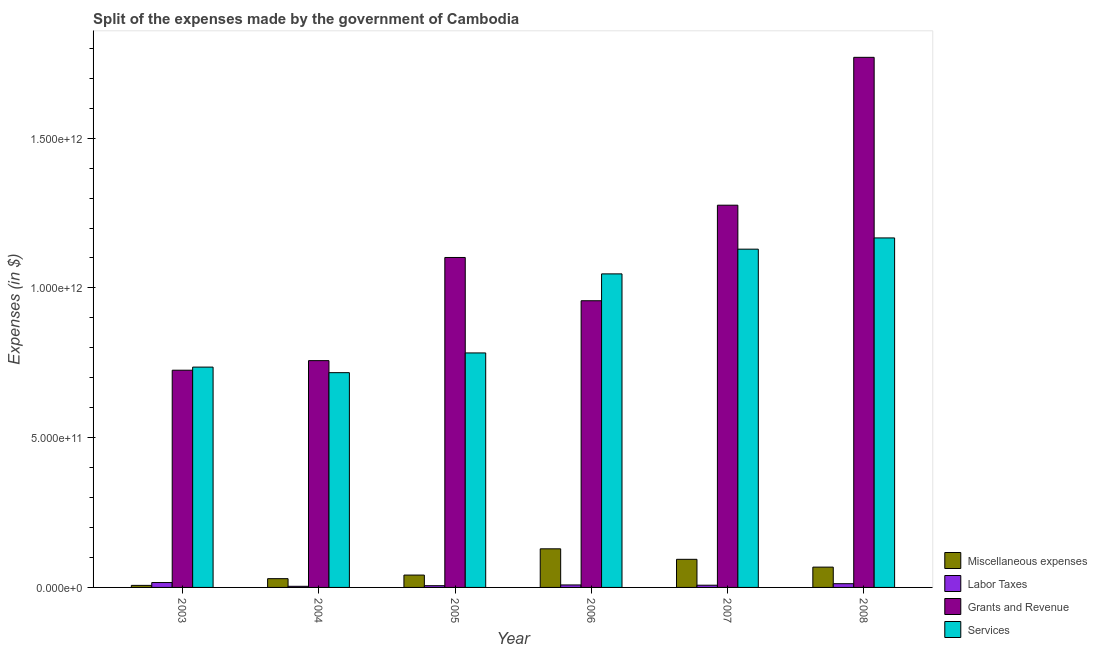How many groups of bars are there?
Your answer should be very brief. 6. How many bars are there on the 6th tick from the right?
Offer a terse response. 4. What is the label of the 5th group of bars from the left?
Provide a short and direct response. 2007. What is the amount spent on grants and revenue in 2008?
Give a very brief answer. 1.77e+12. Across all years, what is the maximum amount spent on grants and revenue?
Make the answer very short. 1.77e+12. Across all years, what is the minimum amount spent on miscellaneous expenses?
Your answer should be very brief. 6.80e+09. In which year was the amount spent on labor taxes maximum?
Make the answer very short. 2003. In which year was the amount spent on labor taxes minimum?
Ensure brevity in your answer.  2004. What is the total amount spent on labor taxes in the graph?
Keep it short and to the point. 5.40e+1. What is the difference between the amount spent on services in 2007 and that in 2008?
Your answer should be compact. -3.75e+1. What is the difference between the amount spent on grants and revenue in 2005 and the amount spent on labor taxes in 2006?
Offer a terse response. 1.44e+11. What is the average amount spent on services per year?
Offer a terse response. 9.30e+11. In the year 2005, what is the difference between the amount spent on services and amount spent on labor taxes?
Offer a terse response. 0. In how many years, is the amount spent on grants and revenue greater than 1100000000000 $?
Ensure brevity in your answer.  3. What is the ratio of the amount spent on grants and revenue in 2006 to that in 2008?
Your response must be concise. 0.54. What is the difference between the highest and the second highest amount spent on labor taxes?
Your answer should be very brief. 3.84e+09. What is the difference between the highest and the lowest amount spent on miscellaneous expenses?
Offer a very short reply. 1.22e+11. In how many years, is the amount spent on miscellaneous expenses greater than the average amount spent on miscellaneous expenses taken over all years?
Offer a very short reply. 3. Is the sum of the amount spent on miscellaneous expenses in 2004 and 2008 greater than the maximum amount spent on services across all years?
Your response must be concise. No. What does the 2nd bar from the left in 2007 represents?
Your response must be concise. Labor Taxes. What does the 2nd bar from the right in 2003 represents?
Provide a succinct answer. Grants and Revenue. How many bars are there?
Your answer should be compact. 24. What is the difference between two consecutive major ticks on the Y-axis?
Keep it short and to the point. 5.00e+11. Are the values on the major ticks of Y-axis written in scientific E-notation?
Provide a succinct answer. Yes. Does the graph contain any zero values?
Offer a very short reply. No. Does the graph contain grids?
Your answer should be compact. No. Where does the legend appear in the graph?
Give a very brief answer. Bottom right. What is the title of the graph?
Provide a succinct answer. Split of the expenses made by the government of Cambodia. Does "SF6 gas" appear as one of the legend labels in the graph?
Ensure brevity in your answer.  No. What is the label or title of the X-axis?
Offer a terse response. Year. What is the label or title of the Y-axis?
Your answer should be compact. Expenses (in $). What is the Expenses (in $) in Miscellaneous expenses in 2003?
Keep it short and to the point. 6.80e+09. What is the Expenses (in $) in Labor Taxes in 2003?
Your answer should be compact. 1.63e+1. What is the Expenses (in $) of Grants and Revenue in 2003?
Provide a succinct answer. 7.25e+11. What is the Expenses (in $) in Services in 2003?
Your answer should be compact. 7.36e+11. What is the Expenses (in $) in Miscellaneous expenses in 2004?
Your response must be concise. 2.93e+1. What is the Expenses (in $) in Labor Taxes in 2004?
Your response must be concise. 3.76e+09. What is the Expenses (in $) of Grants and Revenue in 2004?
Keep it short and to the point. 7.57e+11. What is the Expenses (in $) of Services in 2004?
Your answer should be compact. 7.17e+11. What is the Expenses (in $) in Miscellaneous expenses in 2005?
Offer a terse response. 4.13e+1. What is the Expenses (in $) of Labor Taxes in 2005?
Offer a very short reply. 5.77e+09. What is the Expenses (in $) of Grants and Revenue in 2005?
Make the answer very short. 1.10e+12. What is the Expenses (in $) in Services in 2005?
Your answer should be very brief. 7.83e+11. What is the Expenses (in $) in Miscellaneous expenses in 2006?
Your answer should be compact. 1.29e+11. What is the Expenses (in $) of Labor Taxes in 2006?
Your answer should be very brief. 8.30e+09. What is the Expenses (in $) of Grants and Revenue in 2006?
Your answer should be compact. 9.57e+11. What is the Expenses (in $) of Services in 2006?
Provide a succinct answer. 1.05e+12. What is the Expenses (in $) in Miscellaneous expenses in 2007?
Your answer should be compact. 9.39e+1. What is the Expenses (in $) in Labor Taxes in 2007?
Your answer should be compact. 7.42e+09. What is the Expenses (in $) in Grants and Revenue in 2007?
Give a very brief answer. 1.28e+12. What is the Expenses (in $) in Services in 2007?
Provide a short and direct response. 1.13e+12. What is the Expenses (in $) in Miscellaneous expenses in 2008?
Ensure brevity in your answer.  6.78e+1. What is the Expenses (in $) in Labor Taxes in 2008?
Make the answer very short. 1.25e+1. What is the Expenses (in $) of Grants and Revenue in 2008?
Your response must be concise. 1.77e+12. What is the Expenses (in $) in Services in 2008?
Give a very brief answer. 1.17e+12. Across all years, what is the maximum Expenses (in $) in Miscellaneous expenses?
Offer a very short reply. 1.29e+11. Across all years, what is the maximum Expenses (in $) in Labor Taxes?
Your response must be concise. 1.63e+1. Across all years, what is the maximum Expenses (in $) in Grants and Revenue?
Provide a succinct answer. 1.77e+12. Across all years, what is the maximum Expenses (in $) of Services?
Your answer should be compact. 1.17e+12. Across all years, what is the minimum Expenses (in $) in Miscellaneous expenses?
Offer a very short reply. 6.80e+09. Across all years, what is the minimum Expenses (in $) of Labor Taxes?
Offer a very short reply. 3.76e+09. Across all years, what is the minimum Expenses (in $) of Grants and Revenue?
Provide a succinct answer. 7.25e+11. Across all years, what is the minimum Expenses (in $) of Services?
Your response must be concise. 7.17e+11. What is the total Expenses (in $) of Miscellaneous expenses in the graph?
Provide a short and direct response. 3.68e+11. What is the total Expenses (in $) in Labor Taxes in the graph?
Your answer should be very brief. 5.40e+1. What is the total Expenses (in $) of Grants and Revenue in the graph?
Provide a succinct answer. 6.59e+12. What is the total Expenses (in $) of Services in the graph?
Make the answer very short. 5.58e+12. What is the difference between the Expenses (in $) in Miscellaneous expenses in 2003 and that in 2004?
Keep it short and to the point. -2.25e+1. What is the difference between the Expenses (in $) of Labor Taxes in 2003 and that in 2004?
Make the answer very short. 1.26e+1. What is the difference between the Expenses (in $) in Grants and Revenue in 2003 and that in 2004?
Provide a short and direct response. -3.20e+1. What is the difference between the Expenses (in $) in Services in 2003 and that in 2004?
Keep it short and to the point. 1.86e+1. What is the difference between the Expenses (in $) of Miscellaneous expenses in 2003 and that in 2005?
Your response must be concise. -3.45e+1. What is the difference between the Expenses (in $) of Labor Taxes in 2003 and that in 2005?
Ensure brevity in your answer.  1.05e+1. What is the difference between the Expenses (in $) of Grants and Revenue in 2003 and that in 2005?
Make the answer very short. -3.76e+11. What is the difference between the Expenses (in $) in Services in 2003 and that in 2005?
Provide a succinct answer. -4.73e+1. What is the difference between the Expenses (in $) of Miscellaneous expenses in 2003 and that in 2006?
Ensure brevity in your answer.  -1.22e+11. What is the difference between the Expenses (in $) of Labor Taxes in 2003 and that in 2006?
Your response must be concise. 8.01e+09. What is the difference between the Expenses (in $) in Grants and Revenue in 2003 and that in 2006?
Ensure brevity in your answer.  -2.32e+11. What is the difference between the Expenses (in $) of Services in 2003 and that in 2006?
Offer a terse response. -3.11e+11. What is the difference between the Expenses (in $) in Miscellaneous expenses in 2003 and that in 2007?
Your answer should be compact. -8.71e+1. What is the difference between the Expenses (in $) in Labor Taxes in 2003 and that in 2007?
Your answer should be compact. 8.90e+09. What is the difference between the Expenses (in $) in Grants and Revenue in 2003 and that in 2007?
Provide a succinct answer. -5.51e+11. What is the difference between the Expenses (in $) of Services in 2003 and that in 2007?
Your answer should be compact. -3.94e+11. What is the difference between the Expenses (in $) in Miscellaneous expenses in 2003 and that in 2008?
Provide a succinct answer. -6.10e+1. What is the difference between the Expenses (in $) in Labor Taxes in 2003 and that in 2008?
Provide a succinct answer. 3.84e+09. What is the difference between the Expenses (in $) in Grants and Revenue in 2003 and that in 2008?
Give a very brief answer. -1.04e+12. What is the difference between the Expenses (in $) of Services in 2003 and that in 2008?
Keep it short and to the point. -4.31e+11. What is the difference between the Expenses (in $) in Miscellaneous expenses in 2004 and that in 2005?
Provide a short and direct response. -1.20e+1. What is the difference between the Expenses (in $) of Labor Taxes in 2004 and that in 2005?
Keep it short and to the point. -2.01e+09. What is the difference between the Expenses (in $) of Grants and Revenue in 2004 and that in 2005?
Your response must be concise. -3.44e+11. What is the difference between the Expenses (in $) in Services in 2004 and that in 2005?
Make the answer very short. -6.59e+1. What is the difference between the Expenses (in $) of Miscellaneous expenses in 2004 and that in 2006?
Give a very brief answer. -9.96e+1. What is the difference between the Expenses (in $) in Labor Taxes in 2004 and that in 2006?
Make the answer very short. -4.54e+09. What is the difference between the Expenses (in $) of Grants and Revenue in 2004 and that in 2006?
Keep it short and to the point. -2.00e+11. What is the difference between the Expenses (in $) of Services in 2004 and that in 2006?
Offer a terse response. -3.30e+11. What is the difference between the Expenses (in $) of Miscellaneous expenses in 2004 and that in 2007?
Your response must be concise. -6.46e+1. What is the difference between the Expenses (in $) in Labor Taxes in 2004 and that in 2007?
Offer a very short reply. -3.66e+09. What is the difference between the Expenses (in $) of Grants and Revenue in 2004 and that in 2007?
Your answer should be compact. -5.19e+11. What is the difference between the Expenses (in $) in Services in 2004 and that in 2007?
Make the answer very short. -4.12e+11. What is the difference between the Expenses (in $) of Miscellaneous expenses in 2004 and that in 2008?
Your response must be concise. -3.86e+1. What is the difference between the Expenses (in $) in Labor Taxes in 2004 and that in 2008?
Provide a succinct answer. -8.72e+09. What is the difference between the Expenses (in $) of Grants and Revenue in 2004 and that in 2008?
Give a very brief answer. -1.01e+12. What is the difference between the Expenses (in $) of Services in 2004 and that in 2008?
Offer a terse response. -4.50e+11. What is the difference between the Expenses (in $) in Miscellaneous expenses in 2005 and that in 2006?
Your answer should be compact. -8.76e+1. What is the difference between the Expenses (in $) in Labor Taxes in 2005 and that in 2006?
Offer a terse response. -2.54e+09. What is the difference between the Expenses (in $) of Grants and Revenue in 2005 and that in 2006?
Your answer should be compact. 1.44e+11. What is the difference between the Expenses (in $) in Services in 2005 and that in 2006?
Make the answer very short. -2.64e+11. What is the difference between the Expenses (in $) in Miscellaneous expenses in 2005 and that in 2007?
Keep it short and to the point. -5.26e+1. What is the difference between the Expenses (in $) of Labor Taxes in 2005 and that in 2007?
Your answer should be very brief. -1.65e+09. What is the difference between the Expenses (in $) in Grants and Revenue in 2005 and that in 2007?
Your response must be concise. -1.75e+11. What is the difference between the Expenses (in $) in Services in 2005 and that in 2007?
Provide a short and direct response. -3.46e+11. What is the difference between the Expenses (in $) in Miscellaneous expenses in 2005 and that in 2008?
Provide a succinct answer. -2.66e+1. What is the difference between the Expenses (in $) in Labor Taxes in 2005 and that in 2008?
Your answer should be very brief. -6.71e+09. What is the difference between the Expenses (in $) of Grants and Revenue in 2005 and that in 2008?
Keep it short and to the point. -6.68e+11. What is the difference between the Expenses (in $) in Services in 2005 and that in 2008?
Provide a succinct answer. -3.84e+11. What is the difference between the Expenses (in $) in Miscellaneous expenses in 2006 and that in 2007?
Keep it short and to the point. 3.50e+1. What is the difference between the Expenses (in $) of Labor Taxes in 2006 and that in 2007?
Your response must be concise. 8.87e+08. What is the difference between the Expenses (in $) of Grants and Revenue in 2006 and that in 2007?
Keep it short and to the point. -3.19e+11. What is the difference between the Expenses (in $) in Services in 2006 and that in 2007?
Ensure brevity in your answer.  -8.25e+1. What is the difference between the Expenses (in $) of Miscellaneous expenses in 2006 and that in 2008?
Keep it short and to the point. 6.11e+1. What is the difference between the Expenses (in $) in Labor Taxes in 2006 and that in 2008?
Make the answer very short. -4.17e+09. What is the difference between the Expenses (in $) in Grants and Revenue in 2006 and that in 2008?
Your answer should be very brief. -8.13e+11. What is the difference between the Expenses (in $) in Services in 2006 and that in 2008?
Make the answer very short. -1.20e+11. What is the difference between the Expenses (in $) of Miscellaneous expenses in 2007 and that in 2008?
Provide a short and direct response. 2.60e+1. What is the difference between the Expenses (in $) in Labor Taxes in 2007 and that in 2008?
Your response must be concise. -5.06e+09. What is the difference between the Expenses (in $) of Grants and Revenue in 2007 and that in 2008?
Provide a short and direct response. -4.94e+11. What is the difference between the Expenses (in $) of Services in 2007 and that in 2008?
Your answer should be compact. -3.75e+1. What is the difference between the Expenses (in $) of Miscellaneous expenses in 2003 and the Expenses (in $) of Labor Taxes in 2004?
Your answer should be very brief. 3.04e+09. What is the difference between the Expenses (in $) of Miscellaneous expenses in 2003 and the Expenses (in $) of Grants and Revenue in 2004?
Give a very brief answer. -7.50e+11. What is the difference between the Expenses (in $) in Miscellaneous expenses in 2003 and the Expenses (in $) in Services in 2004?
Provide a succinct answer. -7.10e+11. What is the difference between the Expenses (in $) in Labor Taxes in 2003 and the Expenses (in $) in Grants and Revenue in 2004?
Your response must be concise. -7.41e+11. What is the difference between the Expenses (in $) of Labor Taxes in 2003 and the Expenses (in $) of Services in 2004?
Provide a succinct answer. -7.01e+11. What is the difference between the Expenses (in $) of Grants and Revenue in 2003 and the Expenses (in $) of Services in 2004?
Your response must be concise. 8.16e+09. What is the difference between the Expenses (in $) of Miscellaneous expenses in 2003 and the Expenses (in $) of Labor Taxes in 2005?
Offer a terse response. 1.03e+09. What is the difference between the Expenses (in $) in Miscellaneous expenses in 2003 and the Expenses (in $) in Grants and Revenue in 2005?
Keep it short and to the point. -1.09e+12. What is the difference between the Expenses (in $) of Miscellaneous expenses in 2003 and the Expenses (in $) of Services in 2005?
Ensure brevity in your answer.  -7.76e+11. What is the difference between the Expenses (in $) of Labor Taxes in 2003 and the Expenses (in $) of Grants and Revenue in 2005?
Provide a short and direct response. -1.09e+12. What is the difference between the Expenses (in $) of Labor Taxes in 2003 and the Expenses (in $) of Services in 2005?
Your response must be concise. -7.67e+11. What is the difference between the Expenses (in $) in Grants and Revenue in 2003 and the Expenses (in $) in Services in 2005?
Provide a succinct answer. -5.77e+1. What is the difference between the Expenses (in $) of Miscellaneous expenses in 2003 and the Expenses (in $) of Labor Taxes in 2006?
Give a very brief answer. -1.51e+09. What is the difference between the Expenses (in $) of Miscellaneous expenses in 2003 and the Expenses (in $) of Grants and Revenue in 2006?
Provide a succinct answer. -9.50e+11. What is the difference between the Expenses (in $) in Miscellaneous expenses in 2003 and the Expenses (in $) in Services in 2006?
Your response must be concise. -1.04e+12. What is the difference between the Expenses (in $) in Labor Taxes in 2003 and the Expenses (in $) in Grants and Revenue in 2006?
Provide a short and direct response. -9.41e+11. What is the difference between the Expenses (in $) of Labor Taxes in 2003 and the Expenses (in $) of Services in 2006?
Offer a terse response. -1.03e+12. What is the difference between the Expenses (in $) in Grants and Revenue in 2003 and the Expenses (in $) in Services in 2006?
Your response must be concise. -3.22e+11. What is the difference between the Expenses (in $) in Miscellaneous expenses in 2003 and the Expenses (in $) in Labor Taxes in 2007?
Provide a succinct answer. -6.19e+08. What is the difference between the Expenses (in $) in Miscellaneous expenses in 2003 and the Expenses (in $) in Grants and Revenue in 2007?
Offer a very short reply. -1.27e+12. What is the difference between the Expenses (in $) in Miscellaneous expenses in 2003 and the Expenses (in $) in Services in 2007?
Your answer should be very brief. -1.12e+12. What is the difference between the Expenses (in $) in Labor Taxes in 2003 and the Expenses (in $) in Grants and Revenue in 2007?
Make the answer very short. -1.26e+12. What is the difference between the Expenses (in $) of Labor Taxes in 2003 and the Expenses (in $) of Services in 2007?
Offer a very short reply. -1.11e+12. What is the difference between the Expenses (in $) of Grants and Revenue in 2003 and the Expenses (in $) of Services in 2007?
Offer a very short reply. -4.04e+11. What is the difference between the Expenses (in $) of Miscellaneous expenses in 2003 and the Expenses (in $) of Labor Taxes in 2008?
Your answer should be very brief. -5.68e+09. What is the difference between the Expenses (in $) of Miscellaneous expenses in 2003 and the Expenses (in $) of Grants and Revenue in 2008?
Your answer should be very brief. -1.76e+12. What is the difference between the Expenses (in $) in Miscellaneous expenses in 2003 and the Expenses (in $) in Services in 2008?
Provide a short and direct response. -1.16e+12. What is the difference between the Expenses (in $) of Labor Taxes in 2003 and the Expenses (in $) of Grants and Revenue in 2008?
Your answer should be very brief. -1.75e+12. What is the difference between the Expenses (in $) of Labor Taxes in 2003 and the Expenses (in $) of Services in 2008?
Provide a short and direct response. -1.15e+12. What is the difference between the Expenses (in $) in Grants and Revenue in 2003 and the Expenses (in $) in Services in 2008?
Your answer should be compact. -4.42e+11. What is the difference between the Expenses (in $) of Miscellaneous expenses in 2004 and the Expenses (in $) of Labor Taxes in 2005?
Offer a terse response. 2.35e+1. What is the difference between the Expenses (in $) of Miscellaneous expenses in 2004 and the Expenses (in $) of Grants and Revenue in 2005?
Your response must be concise. -1.07e+12. What is the difference between the Expenses (in $) in Miscellaneous expenses in 2004 and the Expenses (in $) in Services in 2005?
Keep it short and to the point. -7.54e+11. What is the difference between the Expenses (in $) of Labor Taxes in 2004 and the Expenses (in $) of Grants and Revenue in 2005?
Your response must be concise. -1.10e+12. What is the difference between the Expenses (in $) in Labor Taxes in 2004 and the Expenses (in $) in Services in 2005?
Give a very brief answer. -7.79e+11. What is the difference between the Expenses (in $) in Grants and Revenue in 2004 and the Expenses (in $) in Services in 2005?
Offer a very short reply. -2.57e+1. What is the difference between the Expenses (in $) of Miscellaneous expenses in 2004 and the Expenses (in $) of Labor Taxes in 2006?
Give a very brief answer. 2.10e+1. What is the difference between the Expenses (in $) of Miscellaneous expenses in 2004 and the Expenses (in $) of Grants and Revenue in 2006?
Give a very brief answer. -9.28e+11. What is the difference between the Expenses (in $) in Miscellaneous expenses in 2004 and the Expenses (in $) in Services in 2006?
Offer a very short reply. -1.02e+12. What is the difference between the Expenses (in $) of Labor Taxes in 2004 and the Expenses (in $) of Grants and Revenue in 2006?
Make the answer very short. -9.53e+11. What is the difference between the Expenses (in $) in Labor Taxes in 2004 and the Expenses (in $) in Services in 2006?
Make the answer very short. -1.04e+12. What is the difference between the Expenses (in $) in Grants and Revenue in 2004 and the Expenses (in $) in Services in 2006?
Offer a very short reply. -2.90e+11. What is the difference between the Expenses (in $) of Miscellaneous expenses in 2004 and the Expenses (in $) of Labor Taxes in 2007?
Provide a short and direct response. 2.19e+1. What is the difference between the Expenses (in $) in Miscellaneous expenses in 2004 and the Expenses (in $) in Grants and Revenue in 2007?
Provide a short and direct response. -1.25e+12. What is the difference between the Expenses (in $) in Miscellaneous expenses in 2004 and the Expenses (in $) in Services in 2007?
Your answer should be compact. -1.10e+12. What is the difference between the Expenses (in $) of Labor Taxes in 2004 and the Expenses (in $) of Grants and Revenue in 2007?
Ensure brevity in your answer.  -1.27e+12. What is the difference between the Expenses (in $) in Labor Taxes in 2004 and the Expenses (in $) in Services in 2007?
Keep it short and to the point. -1.13e+12. What is the difference between the Expenses (in $) in Grants and Revenue in 2004 and the Expenses (in $) in Services in 2007?
Your response must be concise. -3.72e+11. What is the difference between the Expenses (in $) in Miscellaneous expenses in 2004 and the Expenses (in $) in Labor Taxes in 2008?
Ensure brevity in your answer.  1.68e+1. What is the difference between the Expenses (in $) of Miscellaneous expenses in 2004 and the Expenses (in $) of Grants and Revenue in 2008?
Make the answer very short. -1.74e+12. What is the difference between the Expenses (in $) of Miscellaneous expenses in 2004 and the Expenses (in $) of Services in 2008?
Your response must be concise. -1.14e+12. What is the difference between the Expenses (in $) in Labor Taxes in 2004 and the Expenses (in $) in Grants and Revenue in 2008?
Offer a very short reply. -1.77e+12. What is the difference between the Expenses (in $) of Labor Taxes in 2004 and the Expenses (in $) of Services in 2008?
Provide a short and direct response. -1.16e+12. What is the difference between the Expenses (in $) of Grants and Revenue in 2004 and the Expenses (in $) of Services in 2008?
Give a very brief answer. -4.10e+11. What is the difference between the Expenses (in $) in Miscellaneous expenses in 2005 and the Expenses (in $) in Labor Taxes in 2006?
Offer a terse response. 3.30e+1. What is the difference between the Expenses (in $) in Miscellaneous expenses in 2005 and the Expenses (in $) in Grants and Revenue in 2006?
Ensure brevity in your answer.  -9.16e+11. What is the difference between the Expenses (in $) in Miscellaneous expenses in 2005 and the Expenses (in $) in Services in 2006?
Offer a terse response. -1.01e+12. What is the difference between the Expenses (in $) of Labor Taxes in 2005 and the Expenses (in $) of Grants and Revenue in 2006?
Your response must be concise. -9.51e+11. What is the difference between the Expenses (in $) in Labor Taxes in 2005 and the Expenses (in $) in Services in 2006?
Provide a succinct answer. -1.04e+12. What is the difference between the Expenses (in $) of Grants and Revenue in 2005 and the Expenses (in $) of Services in 2006?
Your answer should be very brief. 5.48e+1. What is the difference between the Expenses (in $) in Miscellaneous expenses in 2005 and the Expenses (in $) in Labor Taxes in 2007?
Your response must be concise. 3.39e+1. What is the difference between the Expenses (in $) in Miscellaneous expenses in 2005 and the Expenses (in $) in Grants and Revenue in 2007?
Provide a short and direct response. -1.23e+12. What is the difference between the Expenses (in $) in Miscellaneous expenses in 2005 and the Expenses (in $) in Services in 2007?
Your response must be concise. -1.09e+12. What is the difference between the Expenses (in $) in Labor Taxes in 2005 and the Expenses (in $) in Grants and Revenue in 2007?
Provide a succinct answer. -1.27e+12. What is the difference between the Expenses (in $) in Labor Taxes in 2005 and the Expenses (in $) in Services in 2007?
Offer a terse response. -1.12e+12. What is the difference between the Expenses (in $) of Grants and Revenue in 2005 and the Expenses (in $) of Services in 2007?
Your response must be concise. -2.78e+1. What is the difference between the Expenses (in $) in Miscellaneous expenses in 2005 and the Expenses (in $) in Labor Taxes in 2008?
Ensure brevity in your answer.  2.88e+1. What is the difference between the Expenses (in $) of Miscellaneous expenses in 2005 and the Expenses (in $) of Grants and Revenue in 2008?
Provide a succinct answer. -1.73e+12. What is the difference between the Expenses (in $) of Miscellaneous expenses in 2005 and the Expenses (in $) of Services in 2008?
Provide a short and direct response. -1.13e+12. What is the difference between the Expenses (in $) in Labor Taxes in 2005 and the Expenses (in $) in Grants and Revenue in 2008?
Keep it short and to the point. -1.76e+12. What is the difference between the Expenses (in $) of Labor Taxes in 2005 and the Expenses (in $) of Services in 2008?
Offer a very short reply. -1.16e+12. What is the difference between the Expenses (in $) of Grants and Revenue in 2005 and the Expenses (in $) of Services in 2008?
Provide a succinct answer. -6.53e+1. What is the difference between the Expenses (in $) of Miscellaneous expenses in 2006 and the Expenses (in $) of Labor Taxes in 2007?
Keep it short and to the point. 1.21e+11. What is the difference between the Expenses (in $) in Miscellaneous expenses in 2006 and the Expenses (in $) in Grants and Revenue in 2007?
Your answer should be very brief. -1.15e+12. What is the difference between the Expenses (in $) of Miscellaneous expenses in 2006 and the Expenses (in $) of Services in 2007?
Make the answer very short. -1.00e+12. What is the difference between the Expenses (in $) of Labor Taxes in 2006 and the Expenses (in $) of Grants and Revenue in 2007?
Provide a succinct answer. -1.27e+12. What is the difference between the Expenses (in $) in Labor Taxes in 2006 and the Expenses (in $) in Services in 2007?
Give a very brief answer. -1.12e+12. What is the difference between the Expenses (in $) in Grants and Revenue in 2006 and the Expenses (in $) in Services in 2007?
Make the answer very short. -1.72e+11. What is the difference between the Expenses (in $) of Miscellaneous expenses in 2006 and the Expenses (in $) of Labor Taxes in 2008?
Your answer should be compact. 1.16e+11. What is the difference between the Expenses (in $) of Miscellaneous expenses in 2006 and the Expenses (in $) of Grants and Revenue in 2008?
Keep it short and to the point. -1.64e+12. What is the difference between the Expenses (in $) of Miscellaneous expenses in 2006 and the Expenses (in $) of Services in 2008?
Your response must be concise. -1.04e+12. What is the difference between the Expenses (in $) of Labor Taxes in 2006 and the Expenses (in $) of Grants and Revenue in 2008?
Offer a very short reply. -1.76e+12. What is the difference between the Expenses (in $) of Labor Taxes in 2006 and the Expenses (in $) of Services in 2008?
Make the answer very short. -1.16e+12. What is the difference between the Expenses (in $) in Grants and Revenue in 2006 and the Expenses (in $) in Services in 2008?
Give a very brief answer. -2.10e+11. What is the difference between the Expenses (in $) in Miscellaneous expenses in 2007 and the Expenses (in $) in Labor Taxes in 2008?
Keep it short and to the point. 8.14e+1. What is the difference between the Expenses (in $) in Miscellaneous expenses in 2007 and the Expenses (in $) in Grants and Revenue in 2008?
Offer a terse response. -1.68e+12. What is the difference between the Expenses (in $) of Miscellaneous expenses in 2007 and the Expenses (in $) of Services in 2008?
Offer a very short reply. -1.07e+12. What is the difference between the Expenses (in $) in Labor Taxes in 2007 and the Expenses (in $) in Grants and Revenue in 2008?
Keep it short and to the point. -1.76e+12. What is the difference between the Expenses (in $) in Labor Taxes in 2007 and the Expenses (in $) in Services in 2008?
Offer a terse response. -1.16e+12. What is the difference between the Expenses (in $) of Grants and Revenue in 2007 and the Expenses (in $) of Services in 2008?
Give a very brief answer. 1.09e+11. What is the average Expenses (in $) of Miscellaneous expenses per year?
Keep it short and to the point. 6.13e+1. What is the average Expenses (in $) in Labor Taxes per year?
Provide a short and direct response. 9.01e+09. What is the average Expenses (in $) of Grants and Revenue per year?
Your answer should be very brief. 1.10e+12. What is the average Expenses (in $) of Services per year?
Keep it short and to the point. 9.30e+11. In the year 2003, what is the difference between the Expenses (in $) of Miscellaneous expenses and Expenses (in $) of Labor Taxes?
Offer a very short reply. -9.52e+09. In the year 2003, what is the difference between the Expenses (in $) of Miscellaneous expenses and Expenses (in $) of Grants and Revenue?
Make the answer very short. -7.18e+11. In the year 2003, what is the difference between the Expenses (in $) in Miscellaneous expenses and Expenses (in $) in Services?
Your answer should be compact. -7.29e+11. In the year 2003, what is the difference between the Expenses (in $) of Labor Taxes and Expenses (in $) of Grants and Revenue?
Your answer should be compact. -7.09e+11. In the year 2003, what is the difference between the Expenses (in $) in Labor Taxes and Expenses (in $) in Services?
Your answer should be very brief. -7.19e+11. In the year 2003, what is the difference between the Expenses (in $) of Grants and Revenue and Expenses (in $) of Services?
Ensure brevity in your answer.  -1.04e+1. In the year 2004, what is the difference between the Expenses (in $) in Miscellaneous expenses and Expenses (in $) in Labor Taxes?
Give a very brief answer. 2.55e+1. In the year 2004, what is the difference between the Expenses (in $) of Miscellaneous expenses and Expenses (in $) of Grants and Revenue?
Your response must be concise. -7.28e+11. In the year 2004, what is the difference between the Expenses (in $) of Miscellaneous expenses and Expenses (in $) of Services?
Your answer should be compact. -6.88e+11. In the year 2004, what is the difference between the Expenses (in $) of Labor Taxes and Expenses (in $) of Grants and Revenue?
Provide a succinct answer. -7.53e+11. In the year 2004, what is the difference between the Expenses (in $) of Labor Taxes and Expenses (in $) of Services?
Provide a succinct answer. -7.13e+11. In the year 2004, what is the difference between the Expenses (in $) of Grants and Revenue and Expenses (in $) of Services?
Provide a succinct answer. 4.02e+1. In the year 2005, what is the difference between the Expenses (in $) in Miscellaneous expenses and Expenses (in $) in Labor Taxes?
Provide a succinct answer. 3.55e+1. In the year 2005, what is the difference between the Expenses (in $) in Miscellaneous expenses and Expenses (in $) in Grants and Revenue?
Keep it short and to the point. -1.06e+12. In the year 2005, what is the difference between the Expenses (in $) in Miscellaneous expenses and Expenses (in $) in Services?
Provide a short and direct response. -7.42e+11. In the year 2005, what is the difference between the Expenses (in $) in Labor Taxes and Expenses (in $) in Grants and Revenue?
Provide a short and direct response. -1.10e+12. In the year 2005, what is the difference between the Expenses (in $) in Labor Taxes and Expenses (in $) in Services?
Provide a short and direct response. -7.77e+11. In the year 2005, what is the difference between the Expenses (in $) of Grants and Revenue and Expenses (in $) of Services?
Give a very brief answer. 3.19e+11. In the year 2006, what is the difference between the Expenses (in $) of Miscellaneous expenses and Expenses (in $) of Labor Taxes?
Provide a short and direct response. 1.21e+11. In the year 2006, what is the difference between the Expenses (in $) of Miscellaneous expenses and Expenses (in $) of Grants and Revenue?
Provide a short and direct response. -8.28e+11. In the year 2006, what is the difference between the Expenses (in $) in Miscellaneous expenses and Expenses (in $) in Services?
Provide a short and direct response. -9.18e+11. In the year 2006, what is the difference between the Expenses (in $) in Labor Taxes and Expenses (in $) in Grants and Revenue?
Make the answer very short. -9.49e+11. In the year 2006, what is the difference between the Expenses (in $) of Labor Taxes and Expenses (in $) of Services?
Your response must be concise. -1.04e+12. In the year 2006, what is the difference between the Expenses (in $) in Grants and Revenue and Expenses (in $) in Services?
Give a very brief answer. -8.97e+1. In the year 2007, what is the difference between the Expenses (in $) in Miscellaneous expenses and Expenses (in $) in Labor Taxes?
Your response must be concise. 8.64e+1. In the year 2007, what is the difference between the Expenses (in $) in Miscellaneous expenses and Expenses (in $) in Grants and Revenue?
Make the answer very short. -1.18e+12. In the year 2007, what is the difference between the Expenses (in $) of Miscellaneous expenses and Expenses (in $) of Services?
Your answer should be compact. -1.04e+12. In the year 2007, what is the difference between the Expenses (in $) in Labor Taxes and Expenses (in $) in Grants and Revenue?
Offer a very short reply. -1.27e+12. In the year 2007, what is the difference between the Expenses (in $) in Labor Taxes and Expenses (in $) in Services?
Make the answer very short. -1.12e+12. In the year 2007, what is the difference between the Expenses (in $) of Grants and Revenue and Expenses (in $) of Services?
Offer a very short reply. 1.47e+11. In the year 2008, what is the difference between the Expenses (in $) of Miscellaneous expenses and Expenses (in $) of Labor Taxes?
Provide a short and direct response. 5.54e+1. In the year 2008, what is the difference between the Expenses (in $) of Miscellaneous expenses and Expenses (in $) of Grants and Revenue?
Ensure brevity in your answer.  -1.70e+12. In the year 2008, what is the difference between the Expenses (in $) of Miscellaneous expenses and Expenses (in $) of Services?
Make the answer very short. -1.10e+12. In the year 2008, what is the difference between the Expenses (in $) of Labor Taxes and Expenses (in $) of Grants and Revenue?
Your response must be concise. -1.76e+12. In the year 2008, what is the difference between the Expenses (in $) in Labor Taxes and Expenses (in $) in Services?
Your answer should be very brief. -1.15e+12. In the year 2008, what is the difference between the Expenses (in $) in Grants and Revenue and Expenses (in $) in Services?
Offer a very short reply. 6.03e+11. What is the ratio of the Expenses (in $) in Miscellaneous expenses in 2003 to that in 2004?
Give a very brief answer. 0.23. What is the ratio of the Expenses (in $) of Labor Taxes in 2003 to that in 2004?
Offer a very short reply. 4.34. What is the ratio of the Expenses (in $) in Grants and Revenue in 2003 to that in 2004?
Make the answer very short. 0.96. What is the ratio of the Expenses (in $) in Services in 2003 to that in 2004?
Make the answer very short. 1.03. What is the ratio of the Expenses (in $) of Miscellaneous expenses in 2003 to that in 2005?
Offer a very short reply. 0.16. What is the ratio of the Expenses (in $) of Labor Taxes in 2003 to that in 2005?
Offer a terse response. 2.83. What is the ratio of the Expenses (in $) of Grants and Revenue in 2003 to that in 2005?
Offer a terse response. 0.66. What is the ratio of the Expenses (in $) in Services in 2003 to that in 2005?
Provide a succinct answer. 0.94. What is the ratio of the Expenses (in $) in Miscellaneous expenses in 2003 to that in 2006?
Give a very brief answer. 0.05. What is the ratio of the Expenses (in $) of Labor Taxes in 2003 to that in 2006?
Ensure brevity in your answer.  1.96. What is the ratio of the Expenses (in $) of Grants and Revenue in 2003 to that in 2006?
Your answer should be compact. 0.76. What is the ratio of the Expenses (in $) of Services in 2003 to that in 2006?
Offer a terse response. 0.7. What is the ratio of the Expenses (in $) in Miscellaneous expenses in 2003 to that in 2007?
Offer a very short reply. 0.07. What is the ratio of the Expenses (in $) of Labor Taxes in 2003 to that in 2007?
Your response must be concise. 2.2. What is the ratio of the Expenses (in $) of Grants and Revenue in 2003 to that in 2007?
Your answer should be very brief. 0.57. What is the ratio of the Expenses (in $) in Services in 2003 to that in 2007?
Your response must be concise. 0.65. What is the ratio of the Expenses (in $) in Miscellaneous expenses in 2003 to that in 2008?
Provide a succinct answer. 0.1. What is the ratio of the Expenses (in $) in Labor Taxes in 2003 to that in 2008?
Offer a very short reply. 1.31. What is the ratio of the Expenses (in $) of Grants and Revenue in 2003 to that in 2008?
Your answer should be very brief. 0.41. What is the ratio of the Expenses (in $) of Services in 2003 to that in 2008?
Your answer should be very brief. 0.63. What is the ratio of the Expenses (in $) of Miscellaneous expenses in 2004 to that in 2005?
Ensure brevity in your answer.  0.71. What is the ratio of the Expenses (in $) of Labor Taxes in 2004 to that in 2005?
Provide a succinct answer. 0.65. What is the ratio of the Expenses (in $) in Grants and Revenue in 2004 to that in 2005?
Your answer should be very brief. 0.69. What is the ratio of the Expenses (in $) of Services in 2004 to that in 2005?
Your answer should be very brief. 0.92. What is the ratio of the Expenses (in $) of Miscellaneous expenses in 2004 to that in 2006?
Offer a terse response. 0.23. What is the ratio of the Expenses (in $) in Labor Taxes in 2004 to that in 2006?
Keep it short and to the point. 0.45. What is the ratio of the Expenses (in $) of Grants and Revenue in 2004 to that in 2006?
Keep it short and to the point. 0.79. What is the ratio of the Expenses (in $) in Services in 2004 to that in 2006?
Your response must be concise. 0.69. What is the ratio of the Expenses (in $) of Miscellaneous expenses in 2004 to that in 2007?
Keep it short and to the point. 0.31. What is the ratio of the Expenses (in $) of Labor Taxes in 2004 to that in 2007?
Your answer should be compact. 0.51. What is the ratio of the Expenses (in $) in Grants and Revenue in 2004 to that in 2007?
Ensure brevity in your answer.  0.59. What is the ratio of the Expenses (in $) of Services in 2004 to that in 2007?
Ensure brevity in your answer.  0.63. What is the ratio of the Expenses (in $) in Miscellaneous expenses in 2004 to that in 2008?
Provide a succinct answer. 0.43. What is the ratio of the Expenses (in $) of Labor Taxes in 2004 to that in 2008?
Ensure brevity in your answer.  0.3. What is the ratio of the Expenses (in $) in Grants and Revenue in 2004 to that in 2008?
Offer a very short reply. 0.43. What is the ratio of the Expenses (in $) in Services in 2004 to that in 2008?
Offer a terse response. 0.61. What is the ratio of the Expenses (in $) of Miscellaneous expenses in 2005 to that in 2006?
Make the answer very short. 0.32. What is the ratio of the Expenses (in $) in Labor Taxes in 2005 to that in 2006?
Keep it short and to the point. 0.69. What is the ratio of the Expenses (in $) in Grants and Revenue in 2005 to that in 2006?
Your answer should be very brief. 1.15. What is the ratio of the Expenses (in $) of Services in 2005 to that in 2006?
Your response must be concise. 0.75. What is the ratio of the Expenses (in $) of Miscellaneous expenses in 2005 to that in 2007?
Give a very brief answer. 0.44. What is the ratio of the Expenses (in $) in Labor Taxes in 2005 to that in 2007?
Keep it short and to the point. 0.78. What is the ratio of the Expenses (in $) of Grants and Revenue in 2005 to that in 2007?
Ensure brevity in your answer.  0.86. What is the ratio of the Expenses (in $) of Services in 2005 to that in 2007?
Provide a short and direct response. 0.69. What is the ratio of the Expenses (in $) in Miscellaneous expenses in 2005 to that in 2008?
Your answer should be compact. 0.61. What is the ratio of the Expenses (in $) of Labor Taxes in 2005 to that in 2008?
Provide a succinct answer. 0.46. What is the ratio of the Expenses (in $) of Grants and Revenue in 2005 to that in 2008?
Offer a terse response. 0.62. What is the ratio of the Expenses (in $) of Services in 2005 to that in 2008?
Keep it short and to the point. 0.67. What is the ratio of the Expenses (in $) of Miscellaneous expenses in 2006 to that in 2007?
Provide a succinct answer. 1.37. What is the ratio of the Expenses (in $) of Labor Taxes in 2006 to that in 2007?
Offer a very short reply. 1.12. What is the ratio of the Expenses (in $) in Services in 2006 to that in 2007?
Make the answer very short. 0.93. What is the ratio of the Expenses (in $) of Miscellaneous expenses in 2006 to that in 2008?
Provide a succinct answer. 1.9. What is the ratio of the Expenses (in $) in Labor Taxes in 2006 to that in 2008?
Provide a short and direct response. 0.67. What is the ratio of the Expenses (in $) of Grants and Revenue in 2006 to that in 2008?
Provide a short and direct response. 0.54. What is the ratio of the Expenses (in $) of Services in 2006 to that in 2008?
Offer a terse response. 0.9. What is the ratio of the Expenses (in $) of Miscellaneous expenses in 2007 to that in 2008?
Your answer should be very brief. 1.38. What is the ratio of the Expenses (in $) in Labor Taxes in 2007 to that in 2008?
Ensure brevity in your answer.  0.59. What is the ratio of the Expenses (in $) of Grants and Revenue in 2007 to that in 2008?
Your answer should be very brief. 0.72. What is the ratio of the Expenses (in $) of Services in 2007 to that in 2008?
Provide a short and direct response. 0.97. What is the difference between the highest and the second highest Expenses (in $) in Miscellaneous expenses?
Give a very brief answer. 3.50e+1. What is the difference between the highest and the second highest Expenses (in $) of Labor Taxes?
Your answer should be compact. 3.84e+09. What is the difference between the highest and the second highest Expenses (in $) in Grants and Revenue?
Provide a short and direct response. 4.94e+11. What is the difference between the highest and the second highest Expenses (in $) in Services?
Your answer should be compact. 3.75e+1. What is the difference between the highest and the lowest Expenses (in $) of Miscellaneous expenses?
Keep it short and to the point. 1.22e+11. What is the difference between the highest and the lowest Expenses (in $) of Labor Taxes?
Your answer should be very brief. 1.26e+1. What is the difference between the highest and the lowest Expenses (in $) in Grants and Revenue?
Provide a short and direct response. 1.04e+12. What is the difference between the highest and the lowest Expenses (in $) in Services?
Offer a terse response. 4.50e+11. 